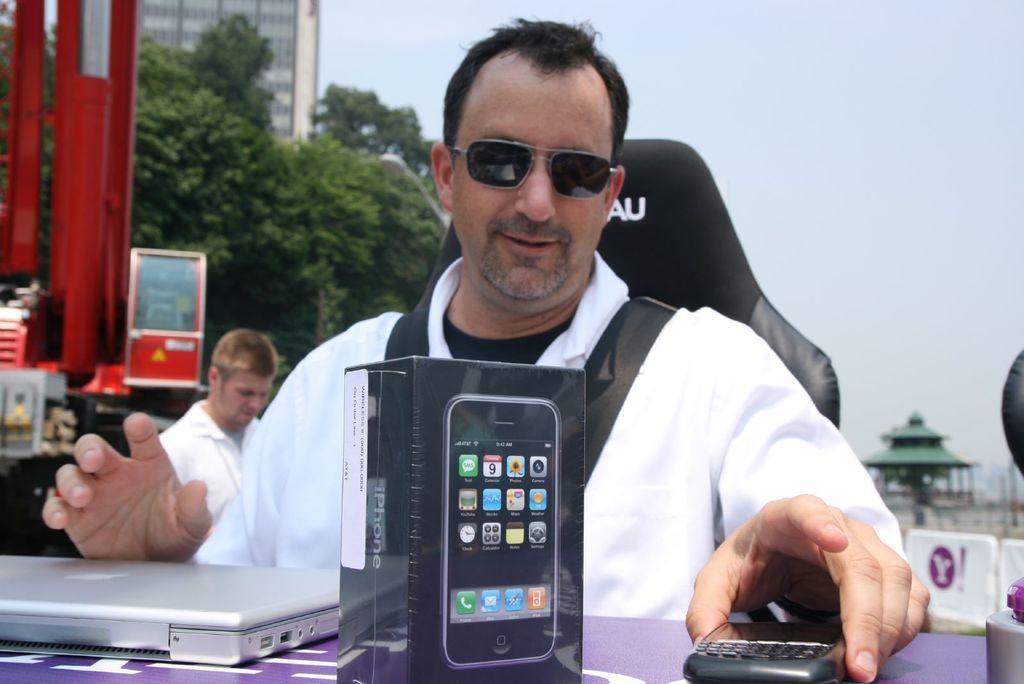Can you describe this image briefly? In the foreground a person is sitting on the chair in front of the table on which laptop, mobile and a box is kept. In the left a truck is visible and building and trees are visible. In the right sky is visible blue in color. In the bottom middle a tomb is visible. In the left bottom a person is standing. This image is taken outside during day time. 